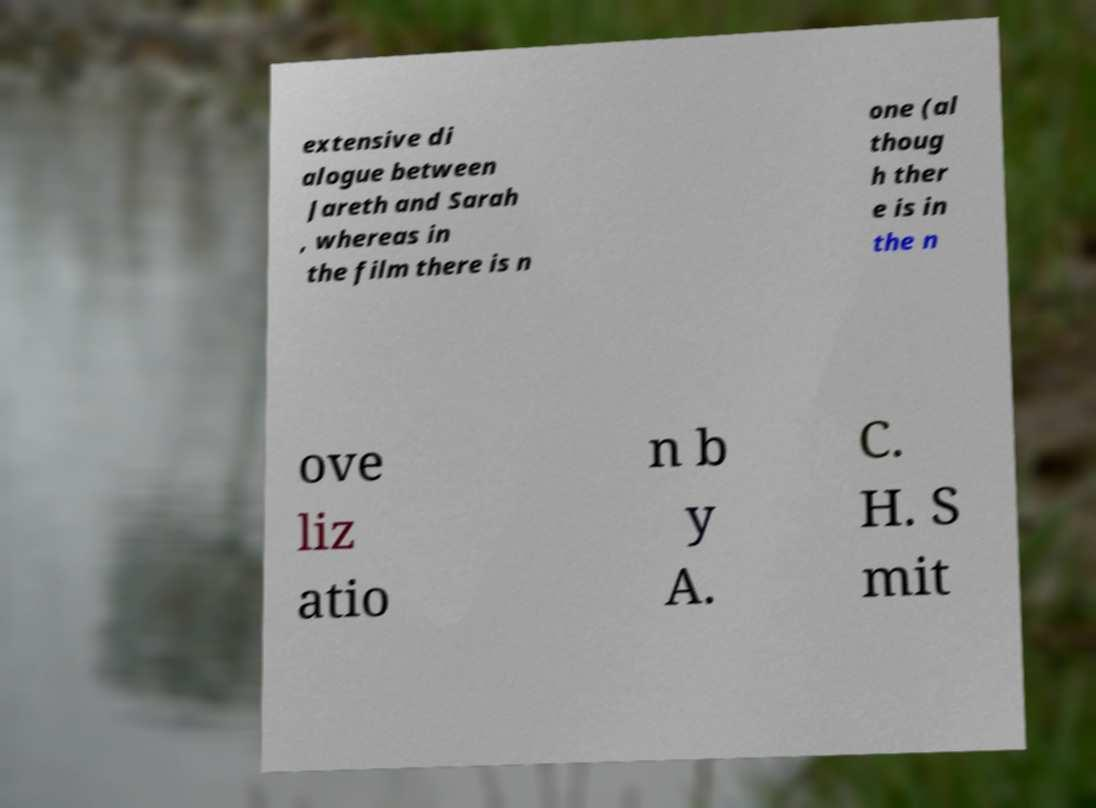I need the written content from this picture converted into text. Can you do that? extensive di alogue between Jareth and Sarah , whereas in the film there is n one (al thoug h ther e is in the n ove liz atio n b y A. C. H. S mit 